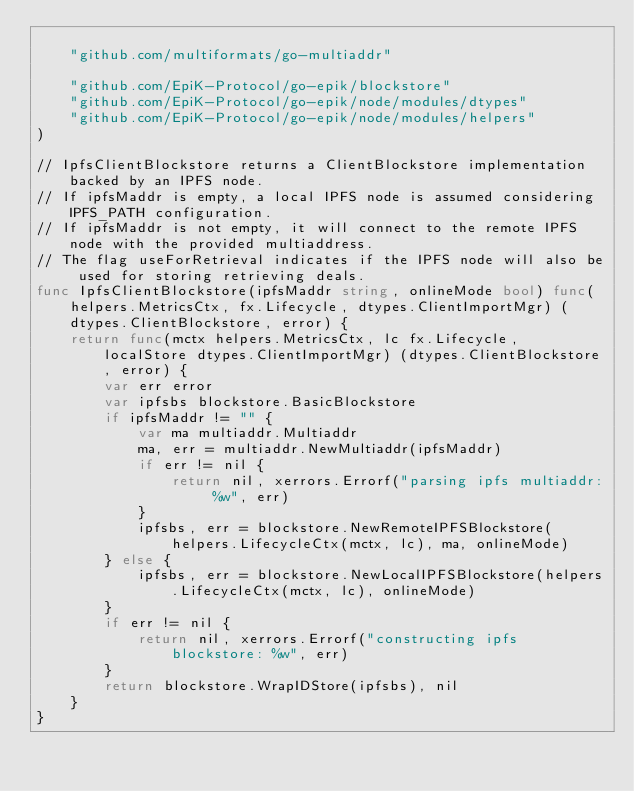Convert code to text. <code><loc_0><loc_0><loc_500><loc_500><_Go_>
	"github.com/multiformats/go-multiaddr"

	"github.com/EpiK-Protocol/go-epik/blockstore"
	"github.com/EpiK-Protocol/go-epik/node/modules/dtypes"
	"github.com/EpiK-Protocol/go-epik/node/modules/helpers"
)

// IpfsClientBlockstore returns a ClientBlockstore implementation backed by an IPFS node.
// If ipfsMaddr is empty, a local IPFS node is assumed considering IPFS_PATH configuration.
// If ipfsMaddr is not empty, it will connect to the remote IPFS node with the provided multiaddress.
// The flag useForRetrieval indicates if the IPFS node will also be used for storing retrieving deals.
func IpfsClientBlockstore(ipfsMaddr string, onlineMode bool) func(helpers.MetricsCtx, fx.Lifecycle, dtypes.ClientImportMgr) (dtypes.ClientBlockstore, error) {
	return func(mctx helpers.MetricsCtx, lc fx.Lifecycle, localStore dtypes.ClientImportMgr) (dtypes.ClientBlockstore, error) {
		var err error
		var ipfsbs blockstore.BasicBlockstore
		if ipfsMaddr != "" {
			var ma multiaddr.Multiaddr
			ma, err = multiaddr.NewMultiaddr(ipfsMaddr)
			if err != nil {
				return nil, xerrors.Errorf("parsing ipfs multiaddr: %w", err)
			}
			ipfsbs, err = blockstore.NewRemoteIPFSBlockstore(helpers.LifecycleCtx(mctx, lc), ma, onlineMode)
		} else {
			ipfsbs, err = blockstore.NewLocalIPFSBlockstore(helpers.LifecycleCtx(mctx, lc), onlineMode)
		}
		if err != nil {
			return nil, xerrors.Errorf("constructing ipfs blockstore: %w", err)
		}
		return blockstore.WrapIDStore(ipfsbs), nil
	}
}
</code> 